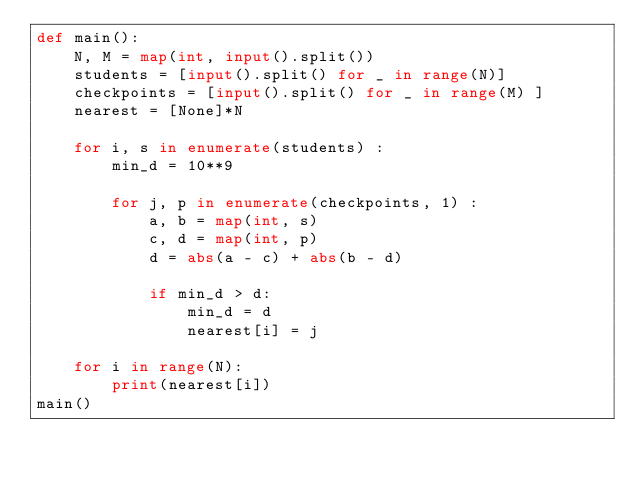Convert code to text. <code><loc_0><loc_0><loc_500><loc_500><_Python_>def main():
    N, M = map(int, input().split())
    students = [input().split() for _ in range(N)]
    checkpoints = [input().split() for _ in range(M) ]
    nearest = [None]*N

    for i, s in enumerate(students) :
        min_d = 10**9

        for j, p in enumerate(checkpoints, 1) :
            a, b = map(int, s)
            c, d = map(int, p)
            d = abs(a - c) + abs(b - d)

            if min_d > d:
                min_d = d
                nearest[i] = j

    for i in range(N):
        print(nearest[i]) 
main()</code> 